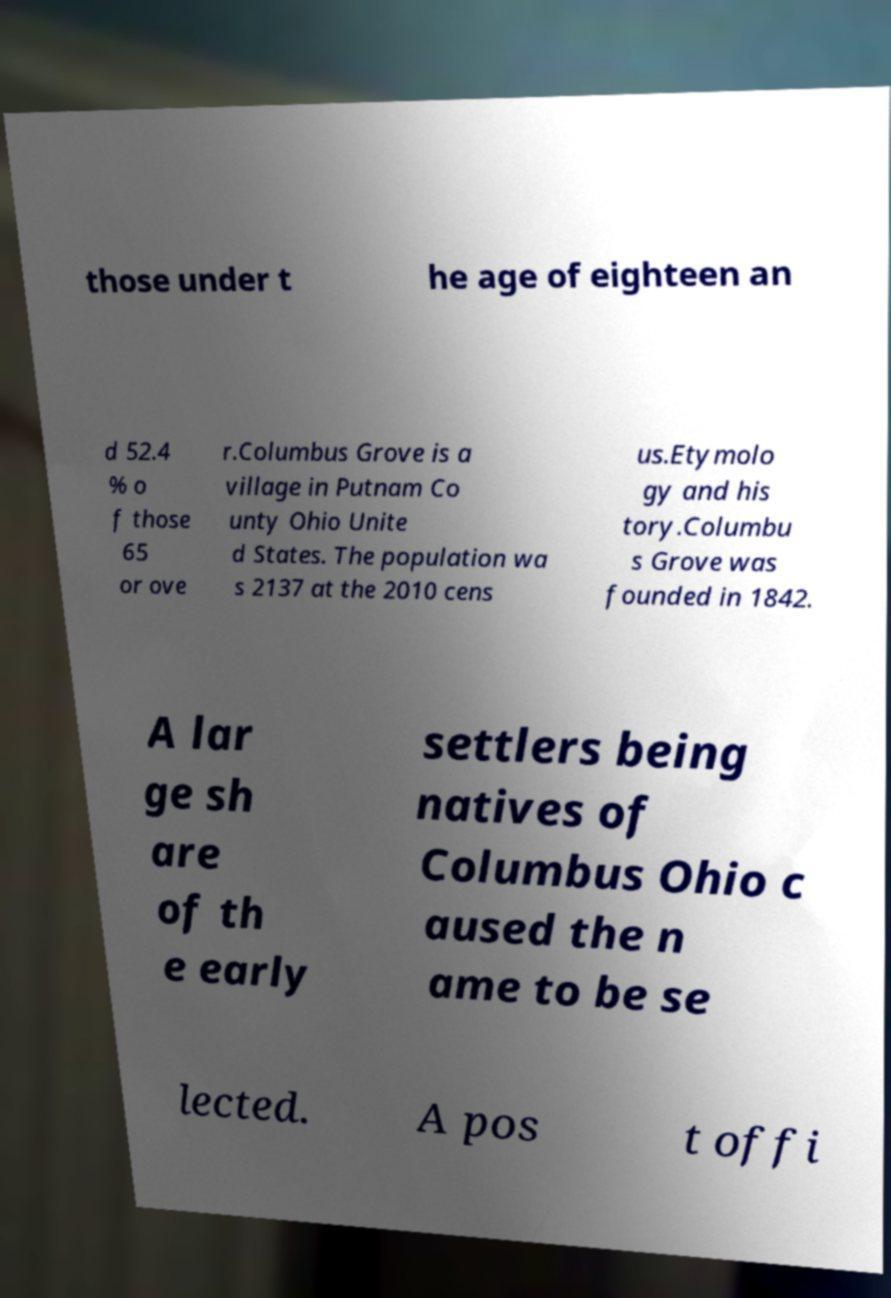There's text embedded in this image that I need extracted. Can you transcribe it verbatim? those under t he age of eighteen an d 52.4 % o f those 65 or ove r.Columbus Grove is a village in Putnam Co unty Ohio Unite d States. The population wa s 2137 at the 2010 cens us.Etymolo gy and his tory.Columbu s Grove was founded in 1842. A lar ge sh are of th e early settlers being natives of Columbus Ohio c aused the n ame to be se lected. A pos t offi 